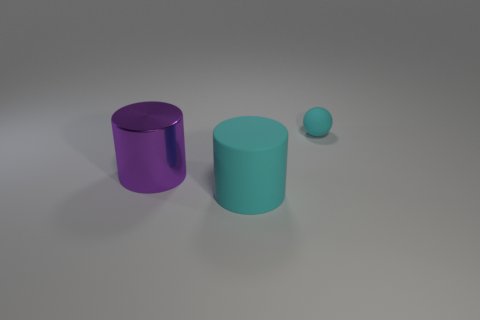Add 2 matte objects. How many objects exist? 5 Subtract all cylinders. How many objects are left? 1 Subtract 0 brown spheres. How many objects are left? 3 Subtract all tiny things. Subtract all tiny brown cylinders. How many objects are left? 2 Add 2 tiny cyan balls. How many tiny cyan balls are left? 3 Add 1 metallic cylinders. How many metallic cylinders exist? 2 